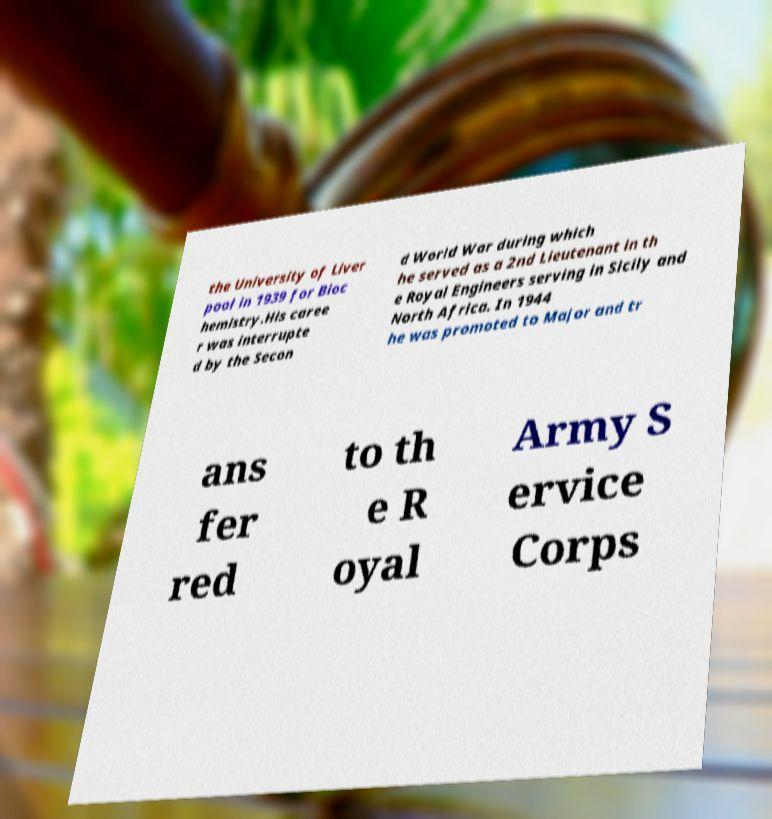I need the written content from this picture converted into text. Can you do that? the University of Liver pool in 1939 for Bioc hemistry.His caree r was interrupte d by the Secon d World War during which he served as a 2nd Lieutenant in th e Royal Engineers serving in Sicily and North Africa. In 1944 he was promoted to Major and tr ans fer red to th e R oyal Army S ervice Corps 